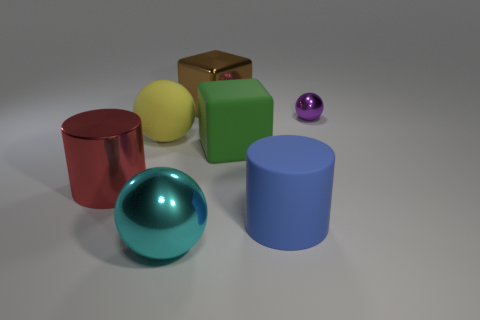Add 1 small yellow things. How many objects exist? 8 Subtract all cylinders. How many objects are left? 5 Add 1 brown objects. How many brown objects exist? 2 Subtract 0 gray spheres. How many objects are left? 7 Subtract all shiny cubes. Subtract all tiny shiny spheres. How many objects are left? 5 Add 1 red metal cylinders. How many red metal cylinders are left? 2 